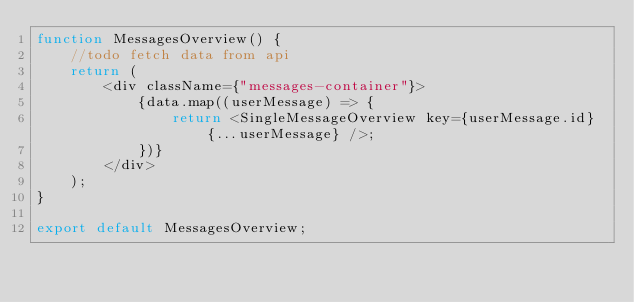<code> <loc_0><loc_0><loc_500><loc_500><_JavaScript_>function MessagesOverview() {
    //todo fetch data from api
    return (
        <div className={"messages-container"}>
            {data.map((userMessage) => {
                return <SingleMessageOverview key={userMessage.id} {...userMessage} />;
            })}
        </div>
    );
}

export default MessagesOverview;
</code> 